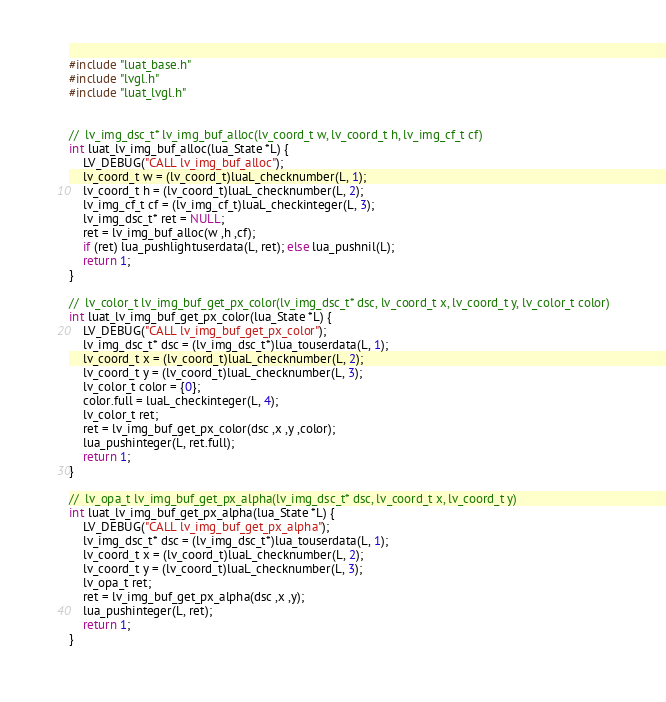Convert code to text. <code><loc_0><loc_0><loc_500><loc_500><_C_>
#include "luat_base.h"
#include "lvgl.h"
#include "luat_lvgl.h"


//  lv_img_dsc_t* lv_img_buf_alloc(lv_coord_t w, lv_coord_t h, lv_img_cf_t cf)
int luat_lv_img_buf_alloc(lua_State *L) {
    LV_DEBUG("CALL lv_img_buf_alloc");
    lv_coord_t w = (lv_coord_t)luaL_checknumber(L, 1);
    lv_coord_t h = (lv_coord_t)luaL_checknumber(L, 2);
    lv_img_cf_t cf = (lv_img_cf_t)luaL_checkinteger(L, 3);
    lv_img_dsc_t* ret = NULL;
    ret = lv_img_buf_alloc(w ,h ,cf);
    if (ret) lua_pushlightuserdata(L, ret); else lua_pushnil(L);
    return 1;
}

//  lv_color_t lv_img_buf_get_px_color(lv_img_dsc_t* dsc, lv_coord_t x, lv_coord_t y, lv_color_t color)
int luat_lv_img_buf_get_px_color(lua_State *L) {
    LV_DEBUG("CALL lv_img_buf_get_px_color");
    lv_img_dsc_t* dsc = (lv_img_dsc_t*)lua_touserdata(L, 1);
    lv_coord_t x = (lv_coord_t)luaL_checknumber(L, 2);
    lv_coord_t y = (lv_coord_t)luaL_checknumber(L, 3);
    lv_color_t color = {0};
    color.full = luaL_checkinteger(L, 4);
    lv_color_t ret;
    ret = lv_img_buf_get_px_color(dsc ,x ,y ,color);
    lua_pushinteger(L, ret.full);
    return 1;
}

//  lv_opa_t lv_img_buf_get_px_alpha(lv_img_dsc_t* dsc, lv_coord_t x, lv_coord_t y)
int luat_lv_img_buf_get_px_alpha(lua_State *L) {
    LV_DEBUG("CALL lv_img_buf_get_px_alpha");
    lv_img_dsc_t* dsc = (lv_img_dsc_t*)lua_touserdata(L, 1);
    lv_coord_t x = (lv_coord_t)luaL_checknumber(L, 2);
    lv_coord_t y = (lv_coord_t)luaL_checknumber(L, 3);
    lv_opa_t ret;
    ret = lv_img_buf_get_px_alpha(dsc ,x ,y);
    lua_pushinteger(L, ret);
    return 1;
}
</code> 